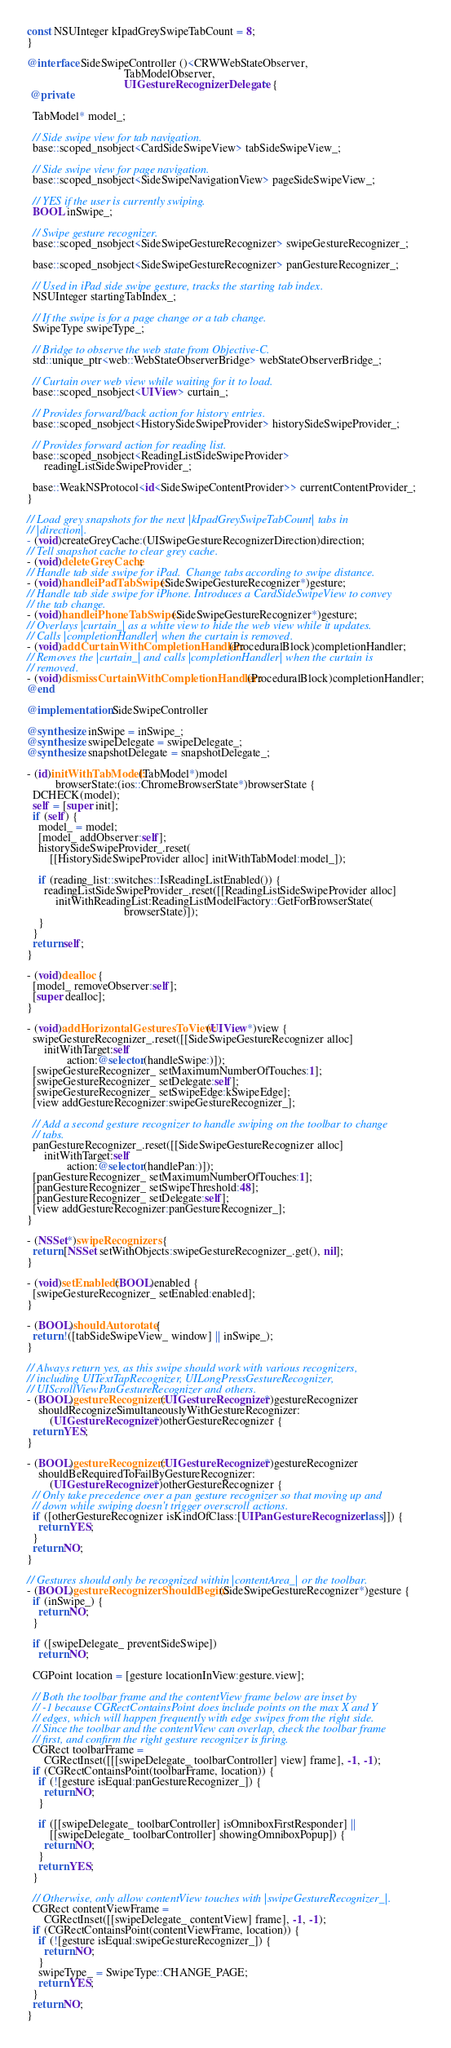<code> <loc_0><loc_0><loc_500><loc_500><_ObjectiveC_>const NSUInteger kIpadGreySwipeTabCount = 8;
}

@interface SideSwipeController ()<CRWWebStateObserver,
                                  TabModelObserver,
                                  UIGestureRecognizerDelegate> {
 @private

  TabModel* model_;

  // Side swipe view for tab navigation.
  base::scoped_nsobject<CardSideSwipeView> tabSideSwipeView_;

  // Side swipe view for page navigation.
  base::scoped_nsobject<SideSwipeNavigationView> pageSideSwipeView_;

  // YES if the user is currently swiping.
  BOOL inSwipe_;

  // Swipe gesture recognizer.
  base::scoped_nsobject<SideSwipeGestureRecognizer> swipeGestureRecognizer_;

  base::scoped_nsobject<SideSwipeGestureRecognizer> panGestureRecognizer_;

  // Used in iPad side swipe gesture, tracks the starting tab index.
  NSUInteger startingTabIndex_;

  // If the swipe is for a page change or a tab change.
  SwipeType swipeType_;

  // Bridge to observe the web state from Objective-C.
  std::unique_ptr<web::WebStateObserverBridge> webStateObserverBridge_;

  // Curtain over web view while waiting for it to load.
  base::scoped_nsobject<UIView> curtain_;

  // Provides forward/back action for history entries.
  base::scoped_nsobject<HistorySideSwipeProvider> historySideSwipeProvider_;

  // Provides forward action for reading list.
  base::scoped_nsobject<ReadingListSideSwipeProvider>
      readingListSideSwipeProvider_;

  base::WeakNSProtocol<id<SideSwipeContentProvider>> currentContentProvider_;
}

// Load grey snapshots for the next |kIpadGreySwipeTabCount| tabs in
// |direction|.
- (void)createGreyCache:(UISwipeGestureRecognizerDirection)direction;
// Tell snapshot cache to clear grey cache.
- (void)deleteGreyCache;
// Handle tab side swipe for iPad.  Change tabs according to swipe distance.
- (void)handleiPadTabSwipe:(SideSwipeGestureRecognizer*)gesture;
// Handle tab side swipe for iPhone. Introduces a CardSideSwipeView to convey
// the tab change.
- (void)handleiPhoneTabSwipe:(SideSwipeGestureRecognizer*)gesture;
// Overlays |curtain_| as a white view to hide the web view while it updates.
// Calls |completionHandler| when the curtain is removed.
- (void)addCurtainWithCompletionHandler:(ProceduralBlock)completionHandler;
// Removes the |curtain_| and calls |completionHandler| when the curtain is
// removed.
- (void)dismissCurtainWithCompletionHandler:(ProceduralBlock)completionHandler;
@end

@implementation SideSwipeController

@synthesize inSwipe = inSwipe_;
@synthesize swipeDelegate = swipeDelegate_;
@synthesize snapshotDelegate = snapshotDelegate_;

- (id)initWithTabModel:(TabModel*)model
          browserState:(ios::ChromeBrowserState*)browserState {
  DCHECK(model);
  self = [super init];
  if (self) {
    model_ = model;
    [model_ addObserver:self];
    historySideSwipeProvider_.reset(
        [[HistorySideSwipeProvider alloc] initWithTabModel:model_]);

    if (reading_list::switches::IsReadingListEnabled()) {
      readingListSideSwipeProvider_.reset([[ReadingListSideSwipeProvider alloc]
          initWithReadingList:ReadingListModelFactory::GetForBrowserState(
                                  browserState)]);
    }
  }
  return self;
}

- (void)dealloc {
  [model_ removeObserver:self];
  [super dealloc];
}

- (void)addHorizontalGesturesToView:(UIView*)view {
  swipeGestureRecognizer_.reset([[SideSwipeGestureRecognizer alloc]
      initWithTarget:self
              action:@selector(handleSwipe:)]);
  [swipeGestureRecognizer_ setMaximumNumberOfTouches:1];
  [swipeGestureRecognizer_ setDelegate:self];
  [swipeGestureRecognizer_ setSwipeEdge:kSwipeEdge];
  [view addGestureRecognizer:swipeGestureRecognizer_];

  // Add a second gesture recognizer to handle swiping on the toolbar to change
  // tabs.
  panGestureRecognizer_.reset([[SideSwipeGestureRecognizer alloc]
      initWithTarget:self
              action:@selector(handlePan:)]);
  [panGestureRecognizer_ setMaximumNumberOfTouches:1];
  [panGestureRecognizer_ setSwipeThreshold:48];
  [panGestureRecognizer_ setDelegate:self];
  [view addGestureRecognizer:panGestureRecognizer_];
}

- (NSSet*)swipeRecognizers {
  return [NSSet setWithObjects:swipeGestureRecognizer_.get(), nil];
}

- (void)setEnabled:(BOOL)enabled {
  [swipeGestureRecognizer_ setEnabled:enabled];
}

- (BOOL)shouldAutorotate {
  return !([tabSideSwipeView_ window] || inSwipe_);
}

// Always return yes, as this swipe should work with various recognizers,
// including UITextTapRecognizer, UILongPressGestureRecognizer,
// UIScrollViewPanGestureRecognizer and others.
- (BOOL)gestureRecognizer:(UIGestureRecognizer*)gestureRecognizer
    shouldRecognizeSimultaneouslyWithGestureRecognizer:
        (UIGestureRecognizer*)otherGestureRecognizer {
  return YES;
}

- (BOOL)gestureRecognizer:(UIGestureRecognizer*)gestureRecognizer
    shouldBeRequiredToFailByGestureRecognizer:
        (UIGestureRecognizer*)otherGestureRecognizer {
  // Only take precedence over a pan gesture recognizer so that moving up and
  // down while swiping doesn't trigger overscroll actions.
  if ([otherGestureRecognizer isKindOfClass:[UIPanGestureRecognizer class]]) {
    return YES;
  }
  return NO;
}

// Gestures should only be recognized within |contentArea_| or the toolbar.
- (BOOL)gestureRecognizerShouldBegin:(SideSwipeGestureRecognizer*)gesture {
  if (inSwipe_) {
    return NO;
  }

  if ([swipeDelegate_ preventSideSwipe])
    return NO;

  CGPoint location = [gesture locationInView:gesture.view];

  // Both the toolbar frame and the contentView frame below are inset by
  // -1 because CGRectContainsPoint does include points on the max X and Y
  // edges, which will happen frequently with edge swipes from the right side.
  // Since the toolbar and the contentView can overlap, check the toolbar frame
  // first, and confirm the right gesture recognizer is firing.
  CGRect toolbarFrame =
      CGRectInset([[[swipeDelegate_ toolbarController] view] frame], -1, -1);
  if (CGRectContainsPoint(toolbarFrame, location)) {
    if (![gesture isEqual:panGestureRecognizer_]) {
      return NO;
    }

    if ([[swipeDelegate_ toolbarController] isOmniboxFirstResponder] ||
        [[swipeDelegate_ toolbarController] showingOmniboxPopup]) {
      return NO;
    }
    return YES;
  }

  // Otherwise, only allow contentView touches with |swipeGestureRecognizer_|.
  CGRect contentViewFrame =
      CGRectInset([[swipeDelegate_ contentView] frame], -1, -1);
  if (CGRectContainsPoint(contentViewFrame, location)) {
    if (![gesture isEqual:swipeGestureRecognizer_]) {
      return NO;
    }
    swipeType_ = SwipeType::CHANGE_PAGE;
    return YES;
  }
  return NO;
}
</code> 